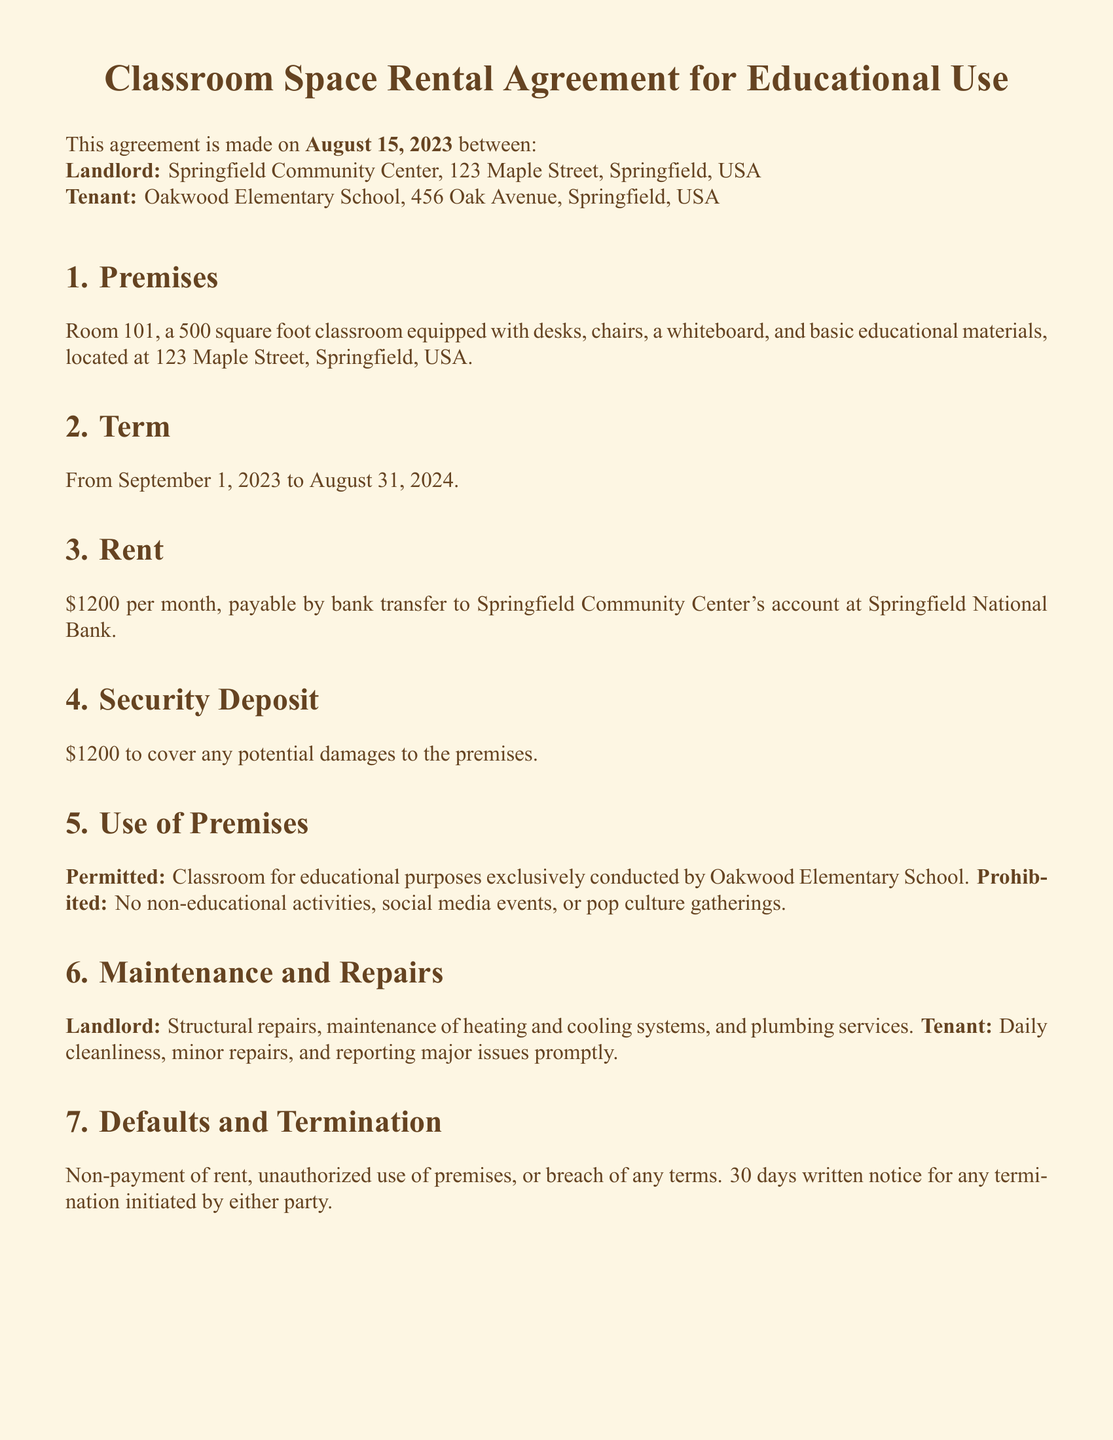What is the address of the landlord? The address of the landlord is listed in the document as Springfield Community Center, 123 Maple Street, Springfield, USA.
Answer: Springfield Community Center, 123 Maple Street, Springfield, USA What is the monthly rent amount? The document specifies that the rent is written as \$1200 per month.
Answer: \$1200 What is the security deposit amount? The agreement notes that the security deposit is the same as the monthly rent, which is \$1200.
Answer: \$1200 What is the start date of the lease? The start date of the lease is indicated in the document as September 1, 2023.
Answer: September 1, 2023 What types of activities are prohibited? The document explicitly states that non-educational activities, social media events, or pop culture gatherings are prohibited.
Answer: Non-educational activities, social media events, pop culture gatherings Who is responsible for structural repairs? The responsibility for structural repairs falls under the landlord as stated in the document.
Answer: Landlord How long is the term of the lease? The lease term is specified in the document and runs from September 1, 2023 to August 31, 2024.
Answer: September 1, 2023 to August 31, 2024 What is required for termination notice? The document requires a 30 days written notice for any termination initiated by either party.
Answer: 30 days written notice What is the governing law for this agreement? The governing law mentioned in the agreement is the State of Springfield Law.
Answer: State of Springfield Law 